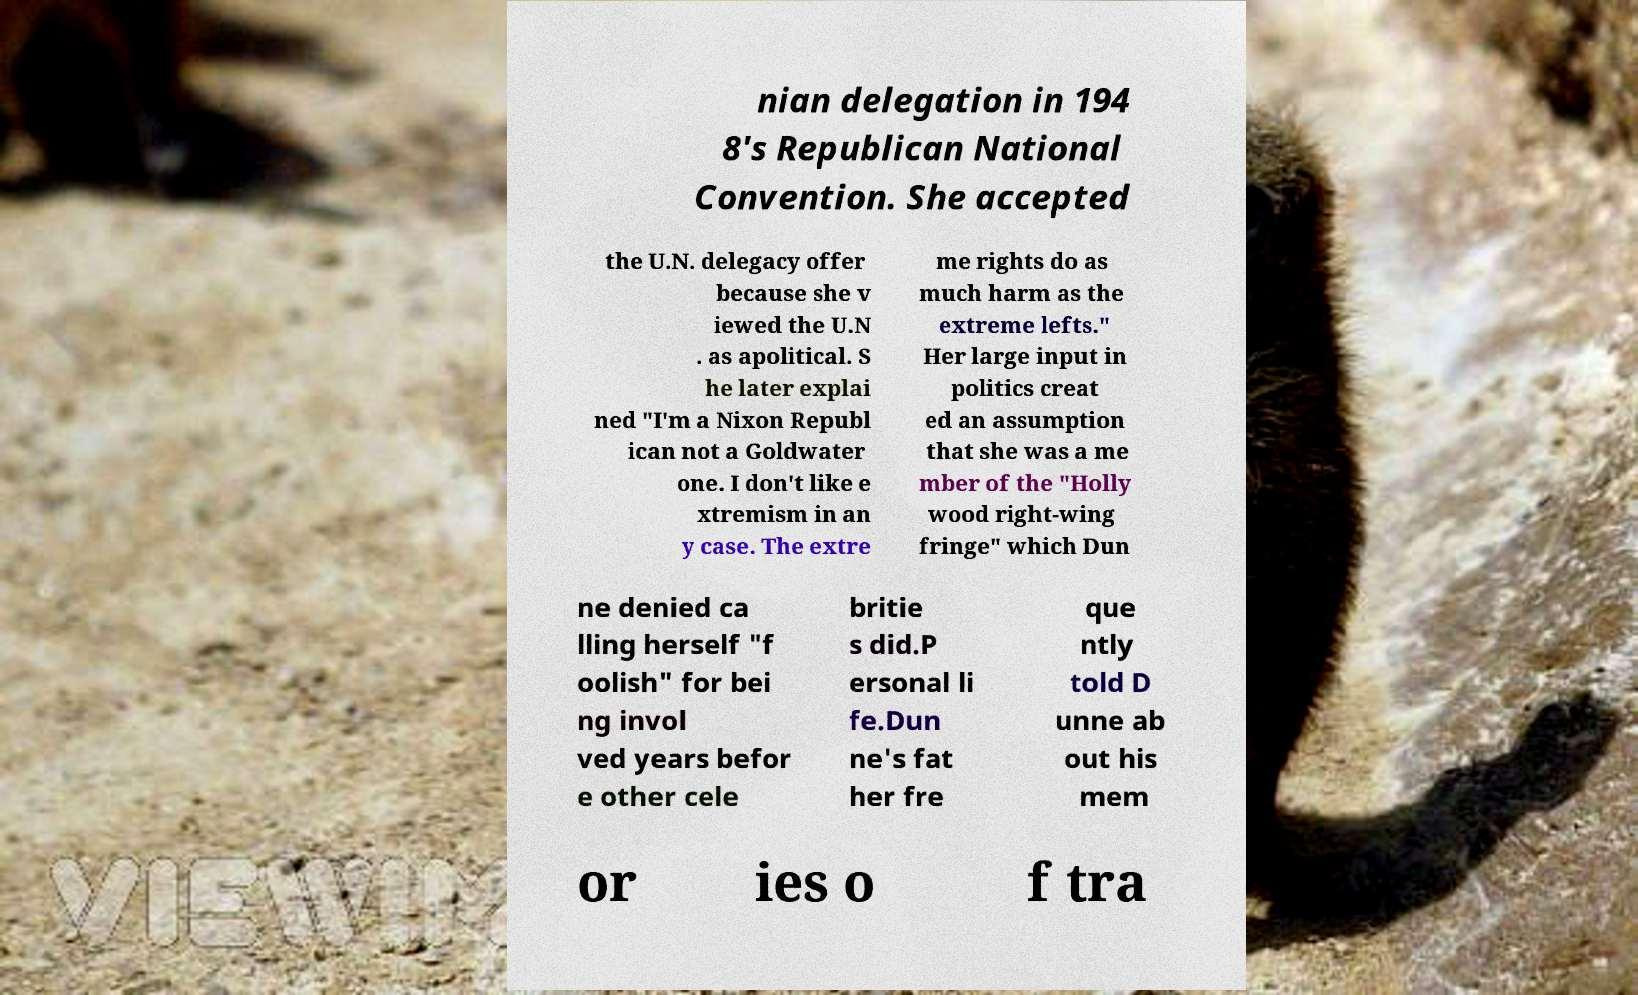What messages or text are displayed in this image? I need them in a readable, typed format. nian delegation in 194 8's Republican National Convention. She accepted the U.N. delegacy offer because she v iewed the U.N . as apolitical. S he later explai ned "I'm a Nixon Republ ican not a Goldwater one. I don't like e xtremism in an y case. The extre me rights do as much harm as the extreme lefts." Her large input in politics creat ed an assumption that she was a me mber of the "Holly wood right-wing fringe" which Dun ne denied ca lling herself "f oolish" for bei ng invol ved years befor e other cele britie s did.P ersonal li fe.Dun ne's fat her fre que ntly told D unne ab out his mem or ies o f tra 